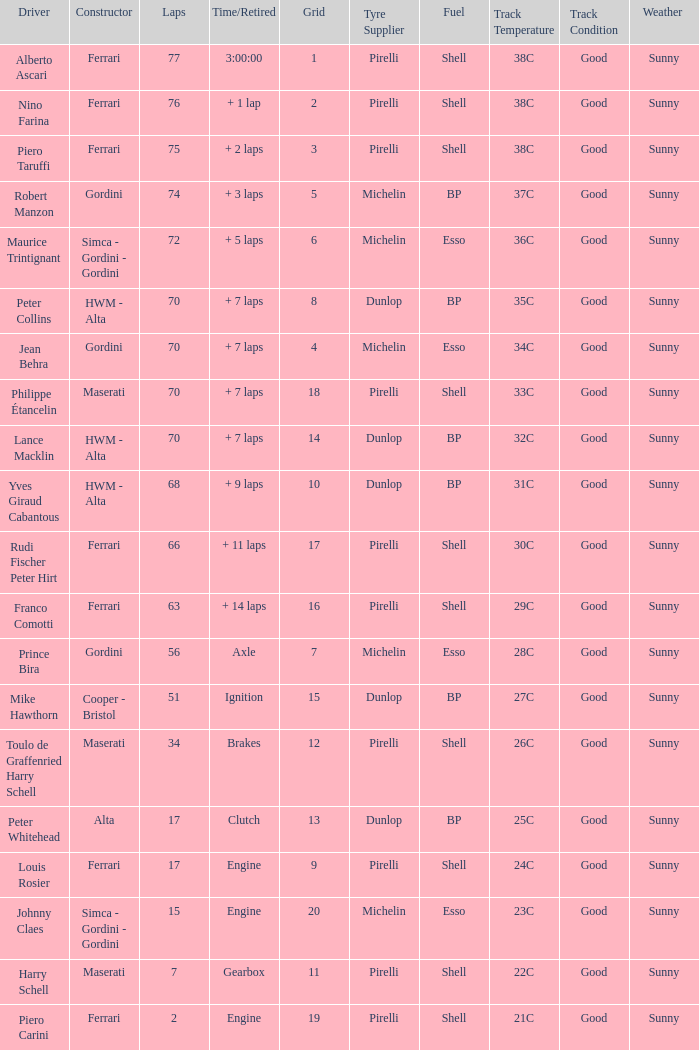How many grids for peter collins? 1.0. 